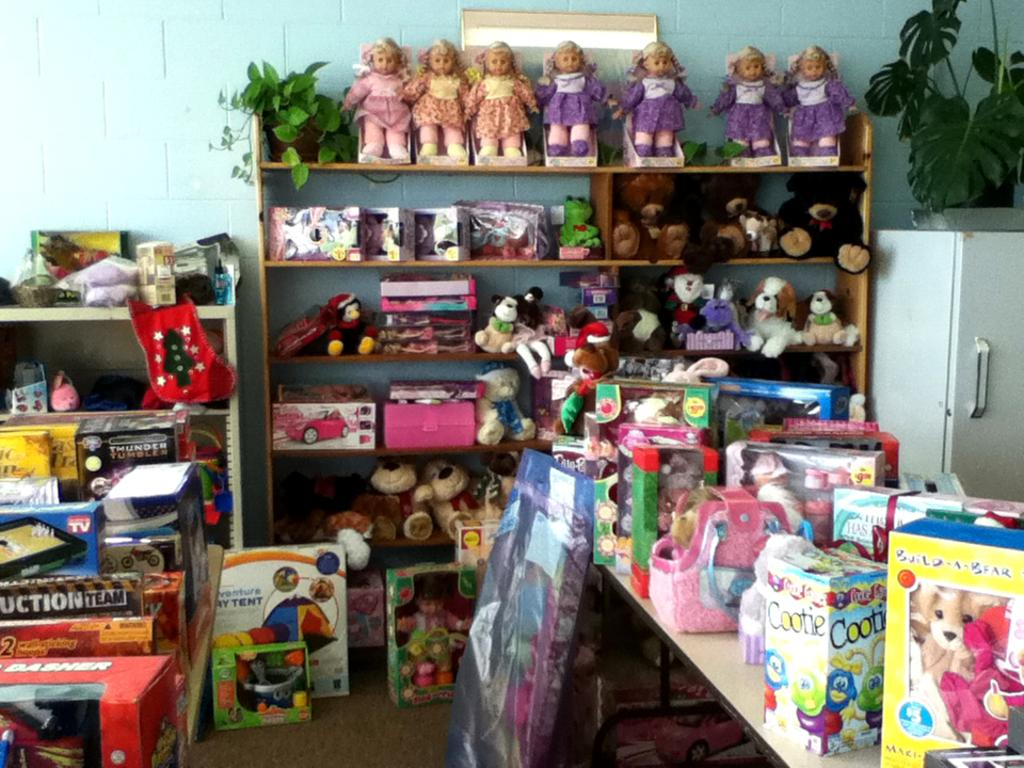Provide a one-sentence caption for the provided image. a group of toys, one of which is build a bear. 